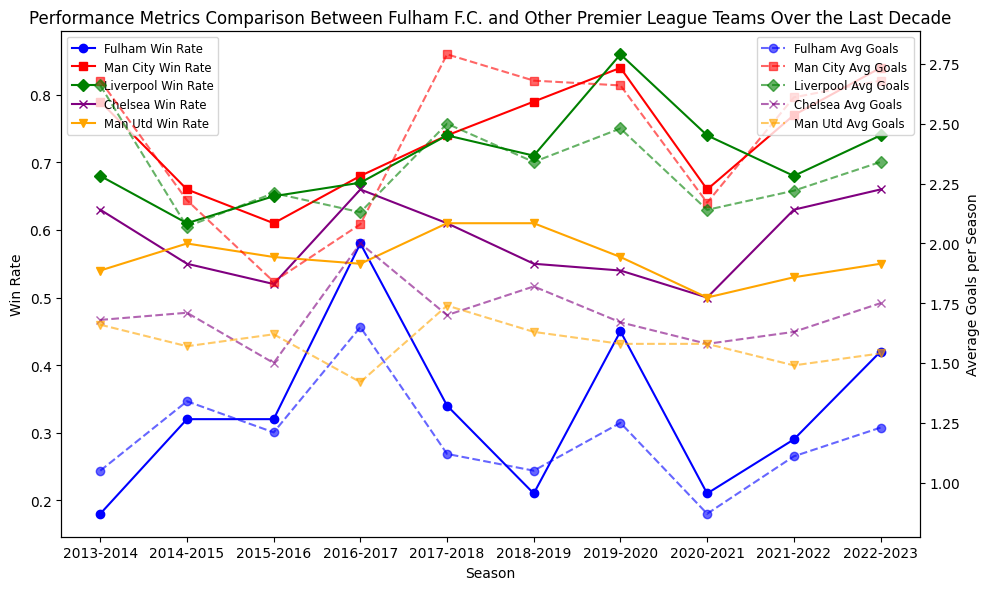Which team has the highest average win rate over the last decade? To identify the team with the highest average win rate, look at the win rate lines over multiple seasons. Manchester City consistently has high win rates, often near or above 0.7.
Answer: Manchester City Between Fulham and Liverpool, which team scored more goals on average in the 2022-2023 season? Check the intersection of the respective lines near the 2022-2023 season for average goals. Liverpool’s line is higher than Fulham’s.
Answer: Liverpool In which seasons did Fulham have a higher win rate than Manchester United? Observe the graph for the seasons where Fulham's win rate line is above Manchester United's. These seasons are 2014-2015, 2016-2017, 2019-2020, and 2022-2023.
Answer: 2014-2015, 2016-2017, 2019-2020, 2022-2023 What is the difference in average goals between Fulham and Chelsea in the 2018-2019 season? Locate the average goals for both teams in the 2018-2019 season. Fulham's average goals are 1.05, and Chelsea's is 1.82. The difference is 1.82 - 1.05.
Answer: 0.77 Which season did Fulham have the lowest average goals, and what was the value? Look for the lowest point in the line for Fulham's average goals. It occurs in the 2020-2021 season, with an average of 0.87 goals.
Answer: 2020-2021, 0.87 From 2016-2017 to 2017-2018, did Fulham’s win rate increase or decrease, and by how much? Compare Fulham's win rate in these two seasons. It was 0.58 in 2016-2017 and 0.34 in 2017-2018. Subtract the latter from the former.
Answer: Decrease, 0.24 What is the average win rate across all teams for the 2014-2015 season? Add the win rates of all teams in the 2014-2015 season and divide by the number of teams (5). (0.32 + 0.66 + 0.61 + 0.55 + 0.58) / 5.
Answer: 0.544 How does Fulham's average goals across the decade compare to Manchester City’s? Calculate the overall average for each team by summing their averages across all seasons and dividing by the number of seasons. Compare the results. Fulham: 1.18 (approx.), Man City: 2.36 (approx.).
Answer: Lower In which season did Manchester United have the highest win rate, and what was it? Identify the peak point for Manchester United's win rate line. The highest win rate is in the 2013-2014 season with a rate of 0.54.
Answer: 2013-2014, 0.54 